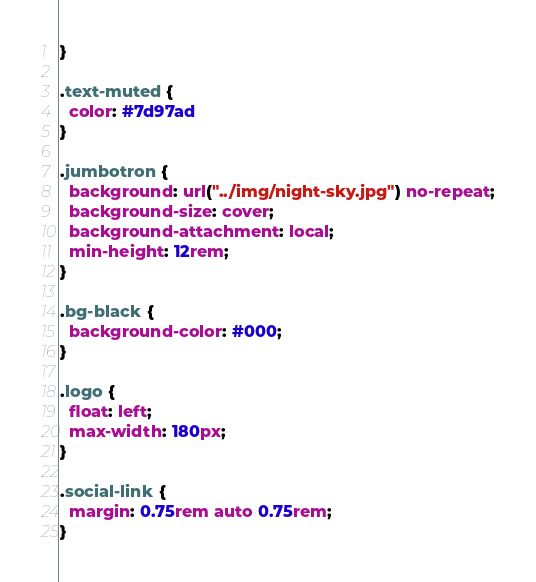Convert code to text. <code><loc_0><loc_0><loc_500><loc_500><_CSS_>}

.text-muted {
  color: #7d97ad
}

.jumbotron {
  background: url("../img/night-sky.jpg") no-repeat;
  background-size: cover;
  background-attachment: local;
  min-height: 12rem;
}

.bg-black {
  background-color: #000;
}

.logo {
  float: left;
  max-width: 180px;
}

.social-link {
  margin: 0.75rem auto 0.75rem;
}
</code> 